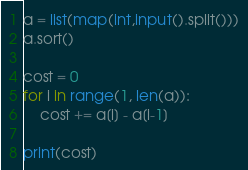Convert code to text. <code><loc_0><loc_0><loc_500><loc_500><_Python_>a = list(map(int,input().split()))
a.sort()

cost = 0
for i in range(1, len(a)):
	cost += a[i] - a[i-1]

print(cost)</code> 